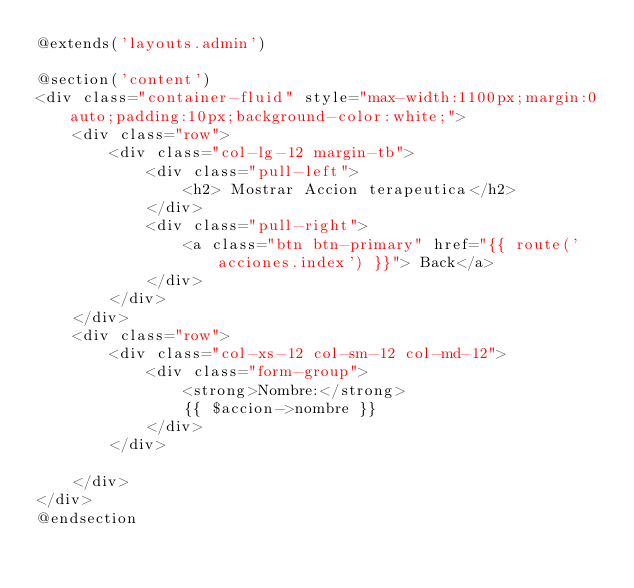Convert code to text. <code><loc_0><loc_0><loc_500><loc_500><_PHP_>@extends('layouts.admin')

@section('content')
<div class="container-fluid" style="max-width:1100px;margin:0 auto;padding:10px;background-color:white;">
    <div class="row">
        <div class="col-lg-12 margin-tb">
            <div class="pull-left">
                <h2> Mostrar Accion terapeutica</h2>
            </div>
            <div class="pull-right">
                <a class="btn btn-primary" href="{{ route('acciones.index') }}"> Back</a>
            </div>
        </div>
    </div>
    <div class="row">
        <div class="col-xs-12 col-sm-12 col-md-12">
            <div class="form-group">
                <strong>Nombre:</strong>
                {{ $accion->nombre }}
            </div>
        </div>
        
    </div>
</div>
@endsection</code> 